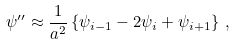<formula> <loc_0><loc_0><loc_500><loc_500>\psi ^ { \prime \prime } \approx \frac { 1 } { a ^ { 2 } } \left \{ \psi _ { i - 1 } - 2 \psi _ { i } + \psi _ { i + 1 } \right \} \, ,</formula> 